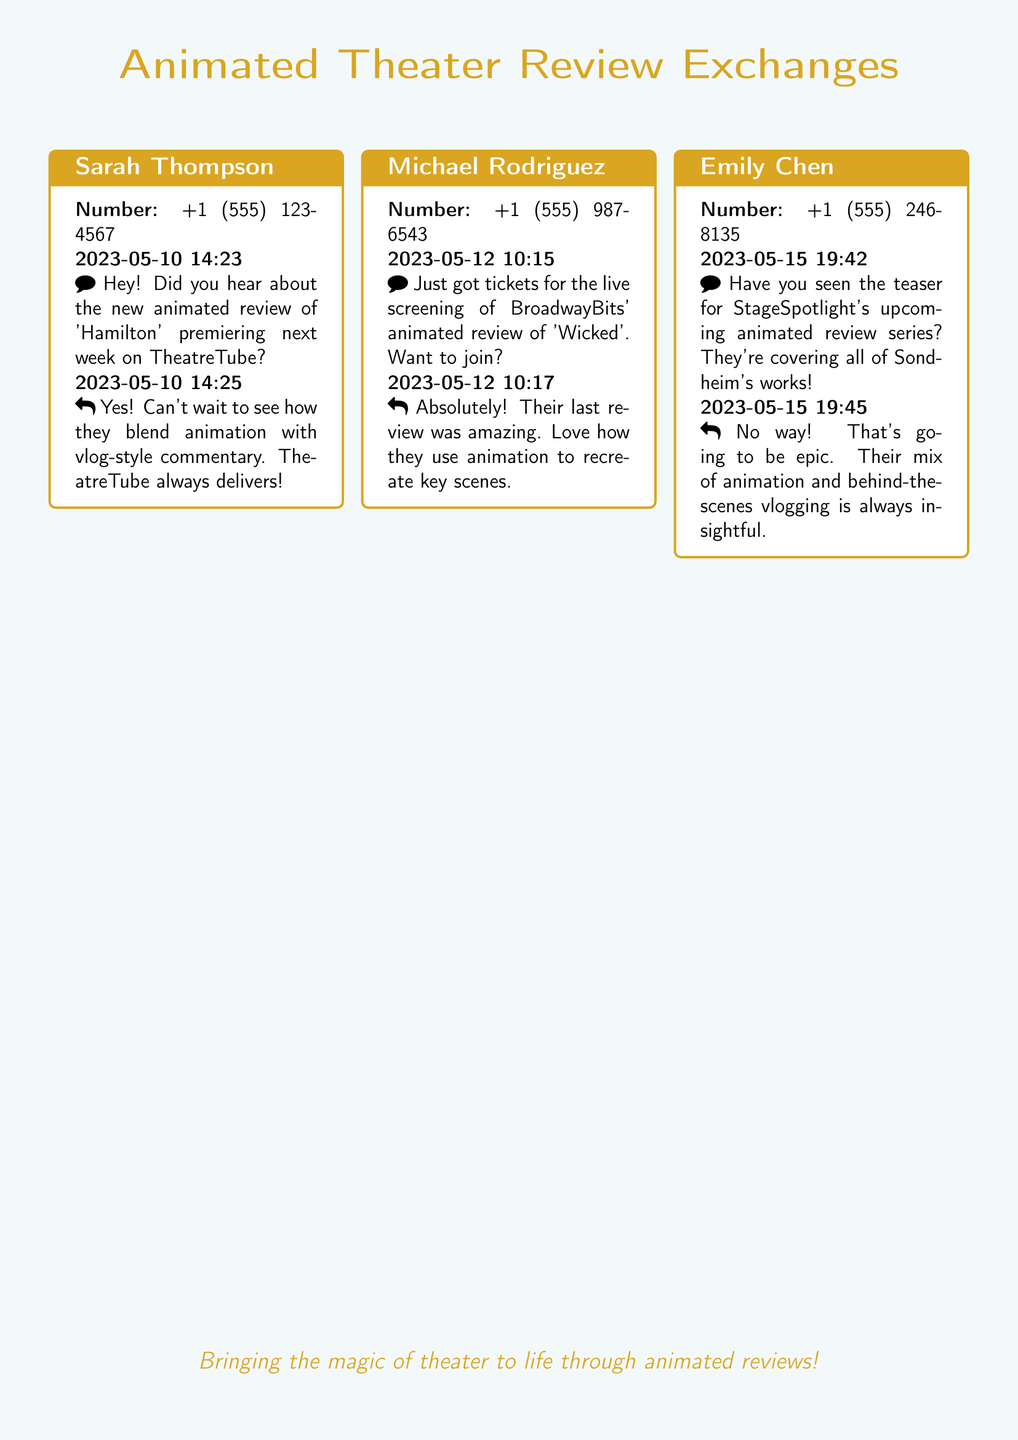What is the title of the animated review premiering on TheatreTube? The title mentioned in the text message is 'Hamilton', which is the focus of the animated review premiering next week.
Answer: Hamilton Who is excited about the animated review of 'Wicked'? Michael Rodriguez expressed excitement about the animated review by stating he got tickets for the live screening, showing his enthusiasm.
Answer: Michael Rodriguez What date is Sarah Thompson's message about the new animated review? Sarah Thompson sent her message on May 10, 2023, as noted in the timestamp of her text.
Answer: 2023-05-10 How does Emily Chen describe StageSpotlight's upcoming series? Emily Chen describes the series as "epic" due to its mix of animation and behind-the-scenes vlogging, showcasing her anticipation for the content.
Answer: epic What is the contact number for Michael Rodriguez? The contact number provided for Michael Rodriguez in the text message exchange is +1 (555) 987-6543.
Answer: +1 (555) 987-6543 What review format is mentioned as being used by TheatreTube? The review format that TheatreTube is mentioned to use is a combination of animation with vlog-style commentary, emphasizing its unique approach.
Answer: animation with vlog-style commentary When did Emily Chen send her text about StageSpotlight's animated review series? The date of Emily Chen's message is May 15, 2023, according to the timestamp included in her message.
Answer: 2023-05-15 What type of content does BroadwayBits focus on according to Michael Rodriguez? BroadwayBits is focused on animated reviews, specifically highlighted by Michael's mention of their animated review of 'Wicked'.
Answer: animated reviews 